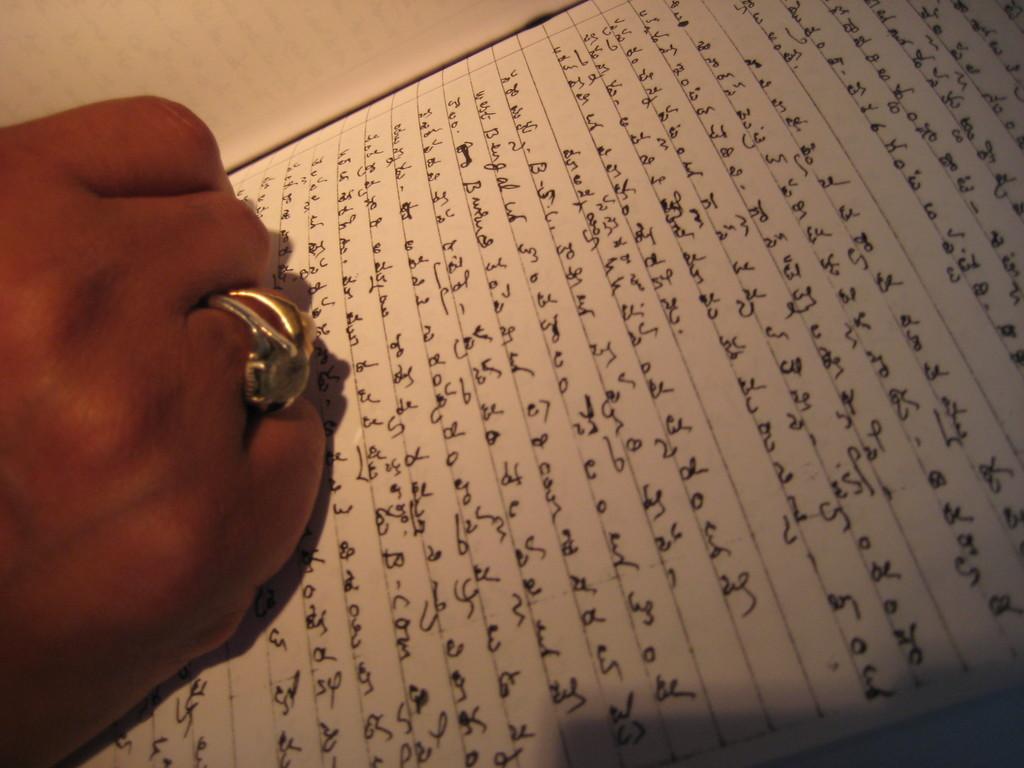Could you give a brief overview of what you see in this image? In the image we can see there is a matter written on the paper with black ink and there is a person wearing rings in his finger. 